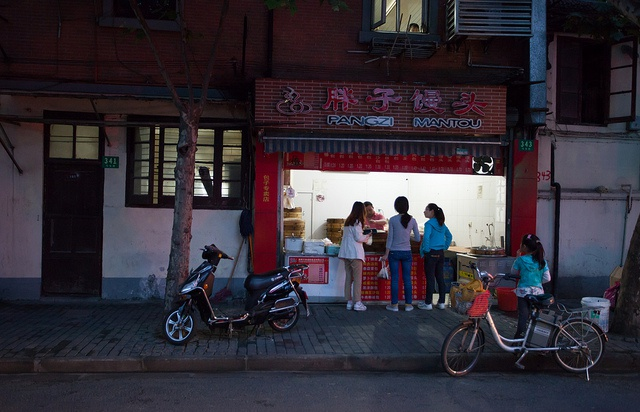Describe the objects in this image and their specific colors. I can see bicycle in black, gray, and blue tones, motorcycle in black, navy, and gray tones, people in black, navy, and gray tones, people in black, blue, teal, and darkblue tones, and people in black, gray, and darkgray tones in this image. 